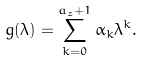Convert formula to latex. <formula><loc_0><loc_0><loc_500><loc_500>g ( \lambda ) = \sum _ { k = 0 } ^ { a _ { z } + 1 } \alpha _ { k } \lambda ^ { k } .</formula> 